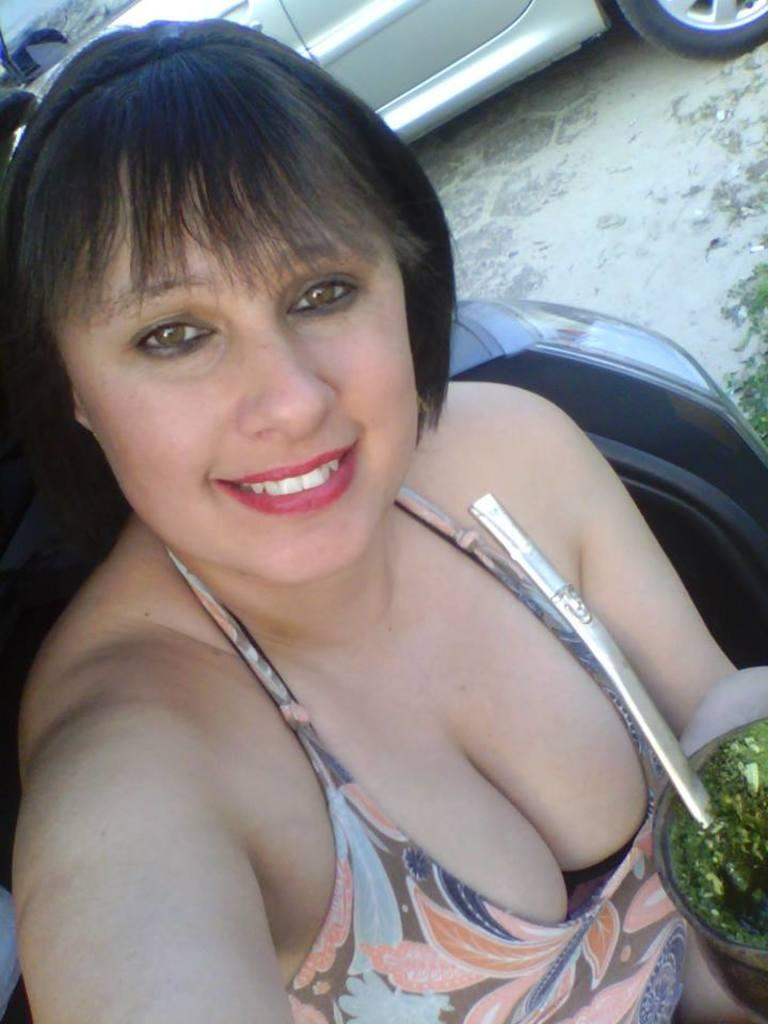Who is present in the image? There is a lady in the image. What is the lady holding in the image? The lady is holding a glass of juice. What is the lady's facial expression in the image? The lady has a smile on her face. What can be seen behind the lady in the image? There are vehicles parked behind her. What is the surface on which the vehicles are parked? The vehicles are parked on a surface. What type of test is the lady conducting in the image? There is no indication in the image that the lady is conducting a test; she is simply holding a glass of juice and smiling. 